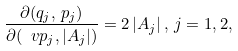Convert formula to latex. <formula><loc_0><loc_0><loc_500><loc_500>\frac { \partial ( q _ { j } , \, p _ { j } ) } { \partial ( \ v p _ { j } , | A _ { j } | ) } = 2 \, | A _ { j } | \, , \, j = 1 , 2 ,</formula> 